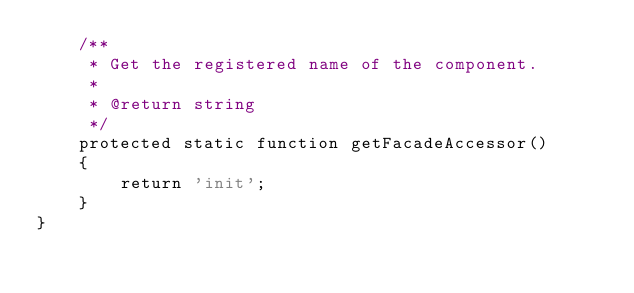Convert code to text. <code><loc_0><loc_0><loc_500><loc_500><_PHP_>    /**
     * Get the registered name of the component.
     *
     * @return string
     */
    protected static function getFacadeAccessor()
    {
        return 'init';
    }
}
</code> 